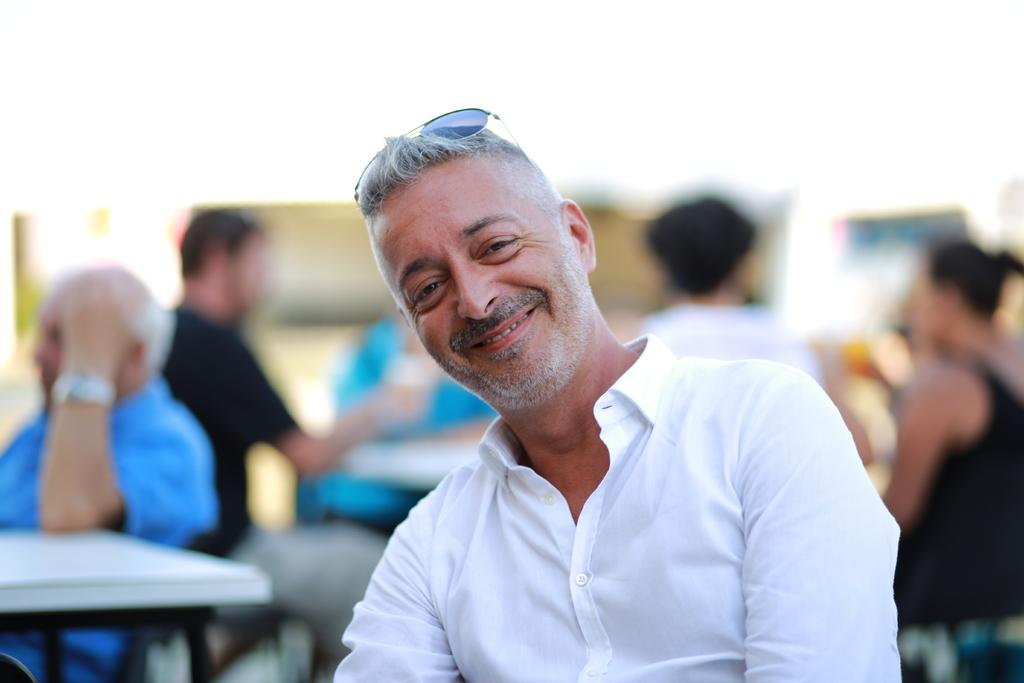Who is the main subject in the image? There is a man in the center of the image. What is the man doing in the image? The man is smiling. What can be seen in the background of the image? There are people sitting in the background of the image. What are the people in the background doing? The people in the background are having a conversation. What book is the man reading in the image? There is no book present in the image, and the man is not reading. 